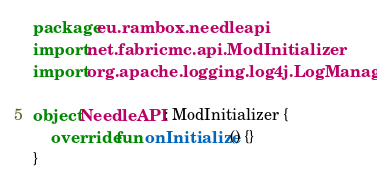Convert code to text. <code><loc_0><loc_0><loc_500><loc_500><_Kotlin_>package eu.rambox.needleapi
import net.fabricmc.api.ModInitializer
import org.apache.logging.log4j.LogManager

object NeedleAPI : ModInitializer {
    override fun onInitialize() {}
}</code> 